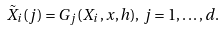<formula> <loc_0><loc_0><loc_500><loc_500>\tilde { X } _ { i } ( j ) = G _ { j } ( X _ { i } , x , h ) , \, j = 1 , \dots , d .</formula> 